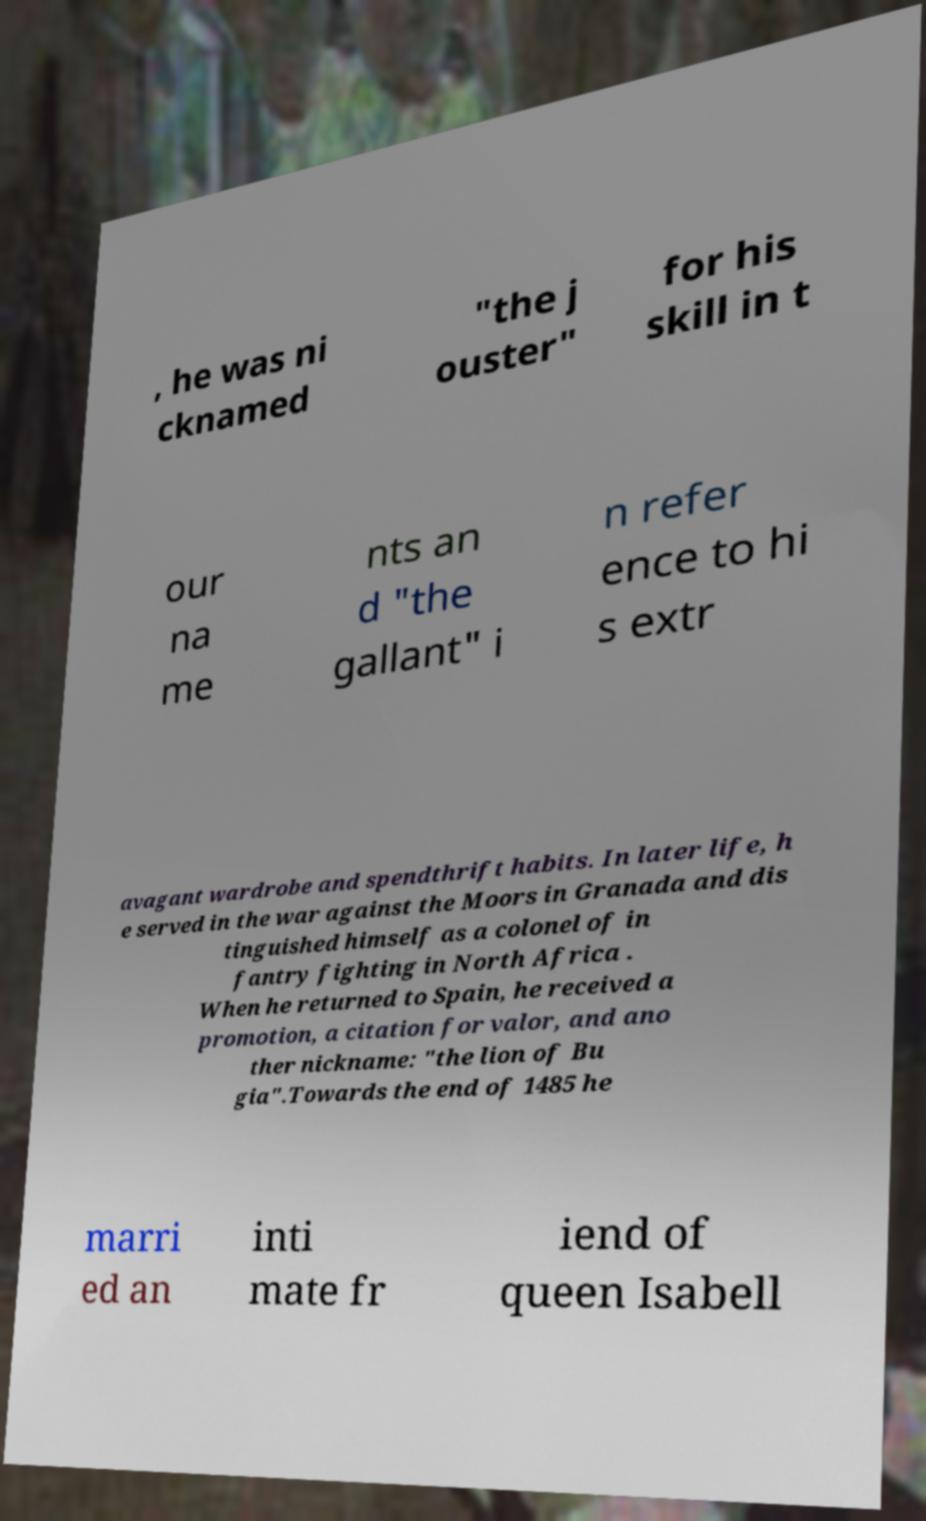Could you assist in decoding the text presented in this image and type it out clearly? , he was ni cknamed "the j ouster" for his skill in t our na me nts an d "the gallant" i n refer ence to hi s extr avagant wardrobe and spendthrift habits. In later life, h e served in the war against the Moors in Granada and dis tinguished himself as a colonel of in fantry fighting in North Africa . When he returned to Spain, he received a promotion, a citation for valor, and ano ther nickname: "the lion of Bu gia".Towards the end of 1485 he marri ed an inti mate fr iend of queen Isabell 